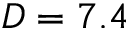<formula> <loc_0><loc_0><loc_500><loc_500>D = 7 . 4</formula> 